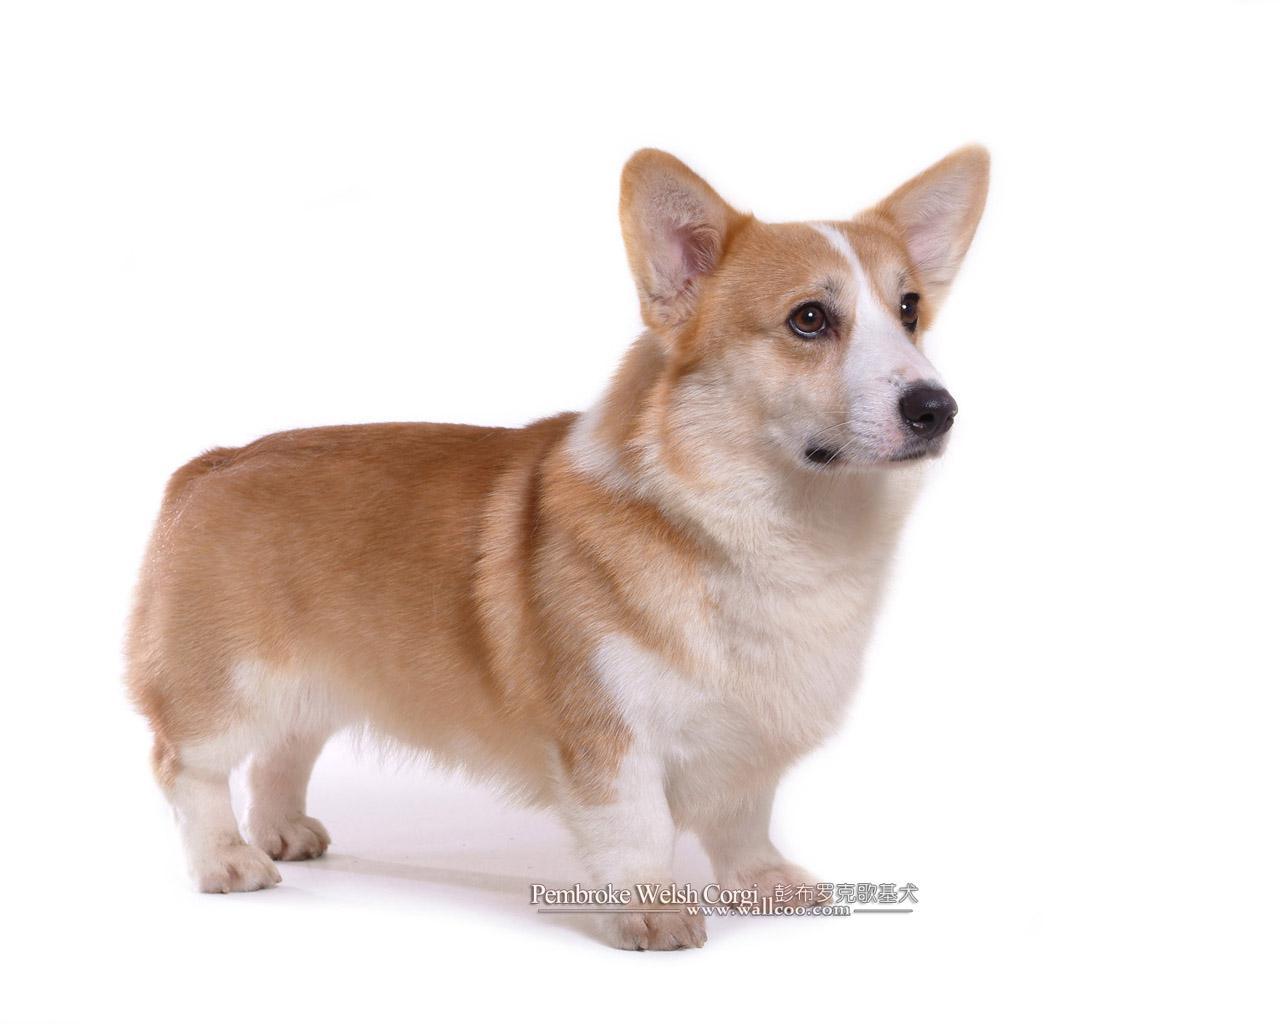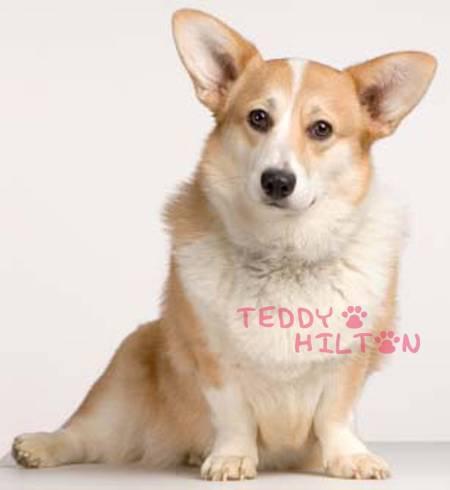The first image is the image on the left, the second image is the image on the right. Given the left and right images, does the statement "One image shows a pair of camera-facing dogs with their heads next to one another." hold true? Answer yes or no. No. The first image is the image on the left, the second image is the image on the right. Analyze the images presented: Is the assertion "The right image contains exactly two dogs." valid? Answer yes or no. No. 